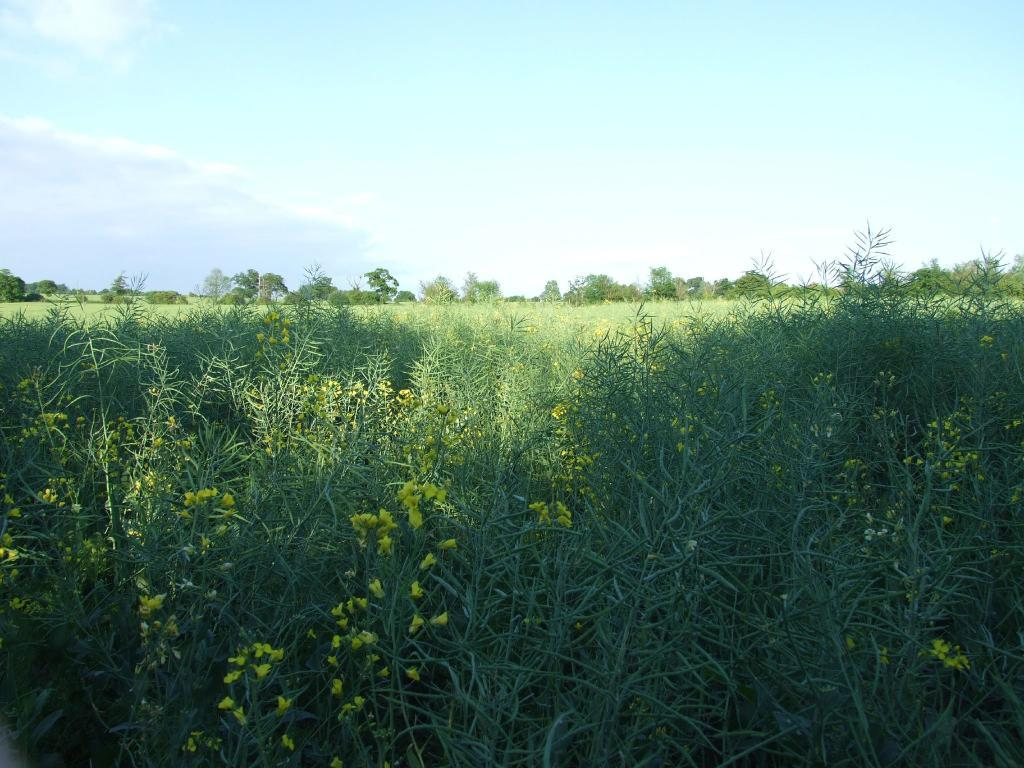What type of plants can be seen in the image? There are plants with yellow flowers in the image. What can be seen in the background of the image? There are trees in the background of the image. What part of the natural environment is visible in the image? The sky is visible in the image. Are there any dinosaurs visible in the image? No, there are no dinosaurs present in the image. What type of liquid can be seen dripping from the yellow flowers in the image? There is no liquid dripping from the yellow flowers in the image; the flowers are not depicted as having any liquid. 